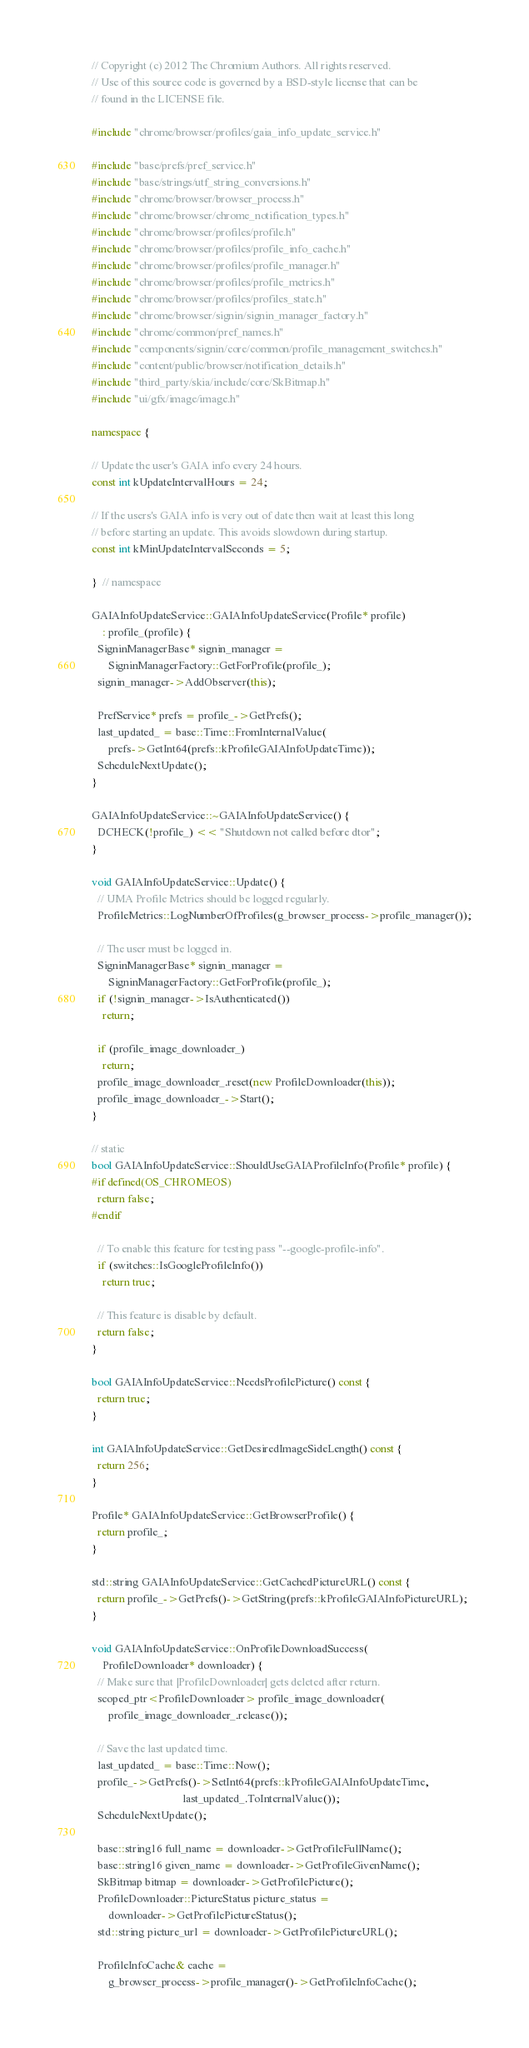Convert code to text. <code><loc_0><loc_0><loc_500><loc_500><_C++_>// Copyright (c) 2012 The Chromium Authors. All rights reserved.
// Use of this source code is governed by a BSD-style license that can be
// found in the LICENSE file.

#include "chrome/browser/profiles/gaia_info_update_service.h"

#include "base/prefs/pref_service.h"
#include "base/strings/utf_string_conversions.h"
#include "chrome/browser/browser_process.h"
#include "chrome/browser/chrome_notification_types.h"
#include "chrome/browser/profiles/profile.h"
#include "chrome/browser/profiles/profile_info_cache.h"
#include "chrome/browser/profiles/profile_manager.h"
#include "chrome/browser/profiles/profile_metrics.h"
#include "chrome/browser/profiles/profiles_state.h"
#include "chrome/browser/signin/signin_manager_factory.h"
#include "chrome/common/pref_names.h"
#include "components/signin/core/common/profile_management_switches.h"
#include "content/public/browser/notification_details.h"
#include "third_party/skia/include/core/SkBitmap.h"
#include "ui/gfx/image/image.h"

namespace {

// Update the user's GAIA info every 24 hours.
const int kUpdateIntervalHours = 24;

// If the users's GAIA info is very out of date then wait at least this long
// before starting an update. This avoids slowdown during startup.
const int kMinUpdateIntervalSeconds = 5;

}  // namespace

GAIAInfoUpdateService::GAIAInfoUpdateService(Profile* profile)
    : profile_(profile) {
  SigninManagerBase* signin_manager =
      SigninManagerFactory::GetForProfile(profile_);
  signin_manager->AddObserver(this);

  PrefService* prefs = profile_->GetPrefs();
  last_updated_ = base::Time::FromInternalValue(
      prefs->GetInt64(prefs::kProfileGAIAInfoUpdateTime));
  ScheduleNextUpdate();
}

GAIAInfoUpdateService::~GAIAInfoUpdateService() {
  DCHECK(!profile_) << "Shutdown not called before dtor";
}

void GAIAInfoUpdateService::Update() {
  // UMA Profile Metrics should be logged regularly.
  ProfileMetrics::LogNumberOfProfiles(g_browser_process->profile_manager());

  // The user must be logged in.
  SigninManagerBase* signin_manager =
      SigninManagerFactory::GetForProfile(profile_);
  if (!signin_manager->IsAuthenticated())
    return;

  if (profile_image_downloader_)
    return;
  profile_image_downloader_.reset(new ProfileDownloader(this));
  profile_image_downloader_->Start();
}

// static
bool GAIAInfoUpdateService::ShouldUseGAIAProfileInfo(Profile* profile) {
#if defined(OS_CHROMEOS)
  return false;
#endif

  // To enable this feature for testing pass "--google-profile-info".
  if (switches::IsGoogleProfileInfo())
    return true;

  // This feature is disable by default.
  return false;
}

bool GAIAInfoUpdateService::NeedsProfilePicture() const {
  return true;
}

int GAIAInfoUpdateService::GetDesiredImageSideLength() const {
  return 256;
}

Profile* GAIAInfoUpdateService::GetBrowserProfile() {
  return profile_;
}

std::string GAIAInfoUpdateService::GetCachedPictureURL() const {
  return profile_->GetPrefs()->GetString(prefs::kProfileGAIAInfoPictureURL);
}

void GAIAInfoUpdateService::OnProfileDownloadSuccess(
    ProfileDownloader* downloader) {
  // Make sure that |ProfileDownloader| gets deleted after return.
  scoped_ptr<ProfileDownloader> profile_image_downloader(
      profile_image_downloader_.release());

  // Save the last updated time.
  last_updated_ = base::Time::Now();
  profile_->GetPrefs()->SetInt64(prefs::kProfileGAIAInfoUpdateTime,
                                 last_updated_.ToInternalValue());
  ScheduleNextUpdate();

  base::string16 full_name = downloader->GetProfileFullName();
  base::string16 given_name = downloader->GetProfileGivenName();
  SkBitmap bitmap = downloader->GetProfilePicture();
  ProfileDownloader::PictureStatus picture_status =
      downloader->GetProfilePictureStatus();
  std::string picture_url = downloader->GetProfilePictureURL();

  ProfileInfoCache& cache =
      g_browser_process->profile_manager()->GetProfileInfoCache();</code> 